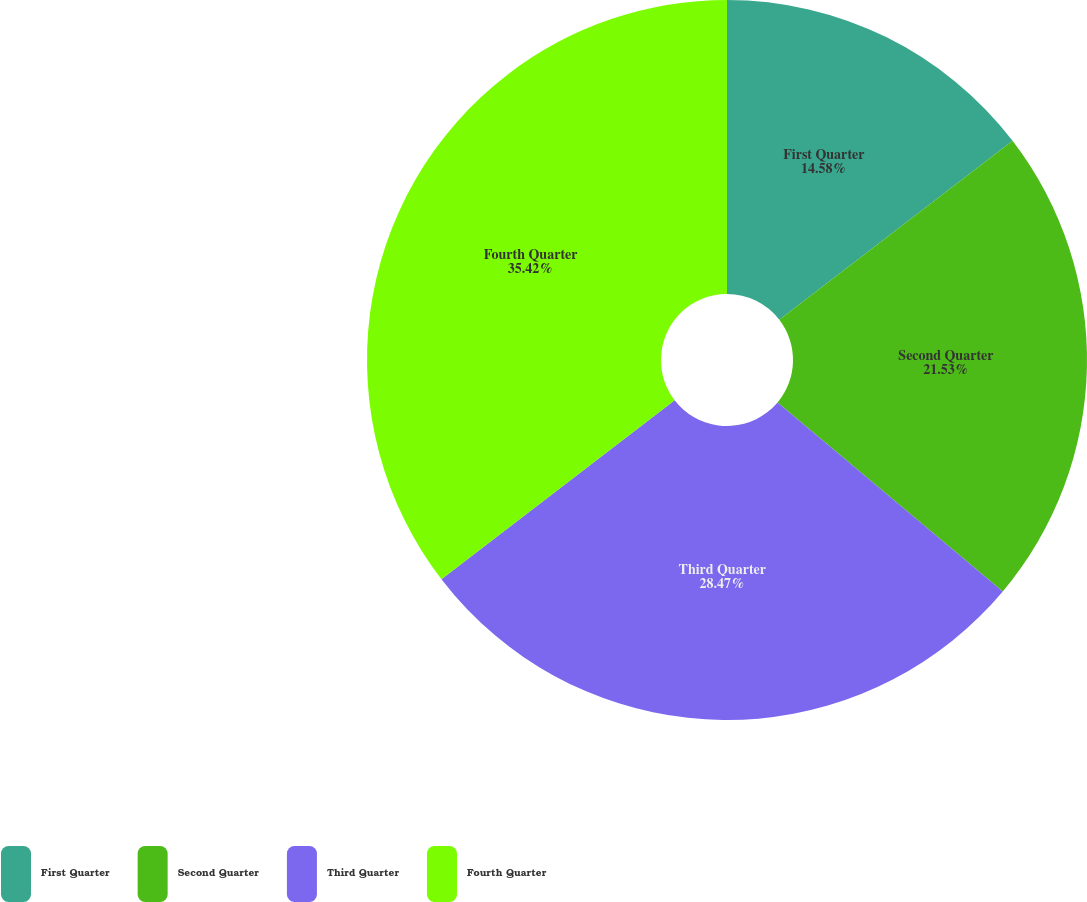Convert chart to OTSL. <chart><loc_0><loc_0><loc_500><loc_500><pie_chart><fcel>First Quarter<fcel>Second Quarter<fcel>Third Quarter<fcel>Fourth Quarter<nl><fcel>14.58%<fcel>21.53%<fcel>28.47%<fcel>35.42%<nl></chart> 